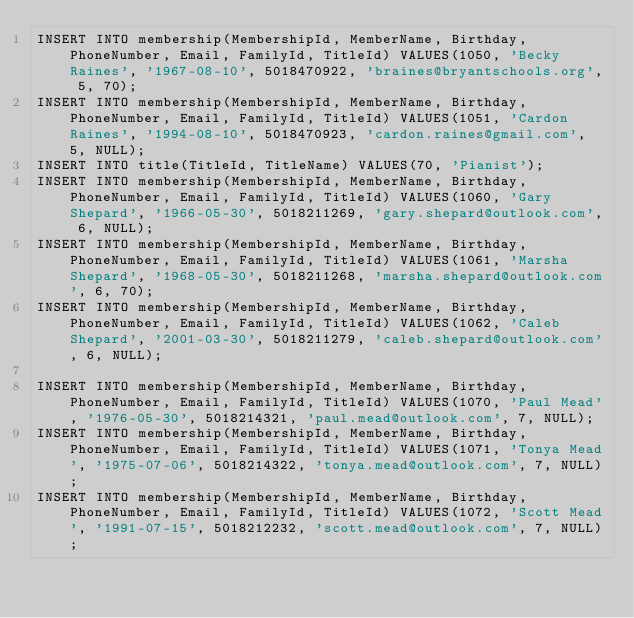<code> <loc_0><loc_0><loc_500><loc_500><_SQL_>INSERT INTO membership(MembershipId, MemberName, Birthday, PhoneNumber, Email, FamilyId, TitleId) VALUES(1050, 'Becky Raines', '1967-08-10', 5018470922, 'braines@bryantschools.org', 5, 70);
INSERT INTO membership(MembershipId, MemberName, Birthday, PhoneNumber, Email, FamilyId, TitleId) VALUES(1051, 'Cardon Raines', '1994-08-10', 5018470923, 'cardon.raines@gmail.com', 5, NULL);
INSERT INTO title(TitleId, TitleName) VALUES(70, 'Pianist');
INSERT INTO membership(MembershipId, MemberName, Birthday, PhoneNumber, Email, FamilyId, TitleId) VALUES(1060, 'Gary Shepard', '1966-05-30', 5018211269, 'gary.shepard@outlook.com', 6, NULL);
INSERT INTO membership(MembershipId, MemberName, Birthday, PhoneNumber, Email, FamilyId, TitleId) VALUES(1061, 'Marsha Shepard', '1968-05-30', 5018211268, 'marsha.shepard@outlook.com', 6, 70);
INSERT INTO membership(MembershipId, MemberName, Birthday, PhoneNumber, Email, FamilyId, TitleId) VALUES(1062, 'Caleb Shepard', '2001-03-30', 5018211279, 'caleb.shepard@outlook.com', 6, NULL);

INSERT INTO membership(MembershipId, MemberName, Birthday, PhoneNumber, Email, FamilyId, TitleId) VALUES(1070, 'Paul Mead', '1976-05-30', 5018214321, 'paul.mead@outlook.com', 7, NULL);
INSERT INTO membership(MembershipId, MemberName, Birthday, PhoneNumber, Email, FamilyId, TitleId) VALUES(1071, 'Tonya Mead', '1975-07-06', 5018214322, 'tonya.mead@outlook.com', 7, NULL);
INSERT INTO membership(MembershipId, MemberName, Birthday, PhoneNumber, Email, FamilyId, TitleId) VALUES(1072, 'Scott Mead', '1991-07-15', 5018212232, 'scott.mead@outlook.com', 7, NULL);</code> 